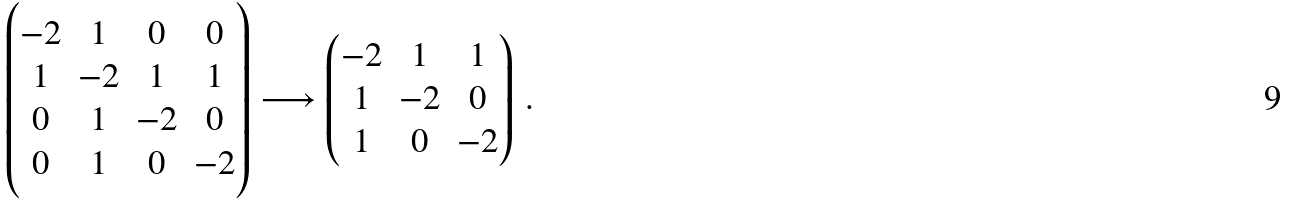Convert formula to latex. <formula><loc_0><loc_0><loc_500><loc_500>\begin{pmatrix} - 2 & 1 & 0 & 0 \\ 1 & - 2 & 1 & 1 \\ 0 & 1 & - 2 & 0 \\ 0 & 1 & 0 & - 2 \end{pmatrix} \longrightarrow \begin{pmatrix} - 2 & 1 & 1 \\ 1 & - 2 & 0 \\ 1 & 0 & - 2 \end{pmatrix} \, .</formula> 